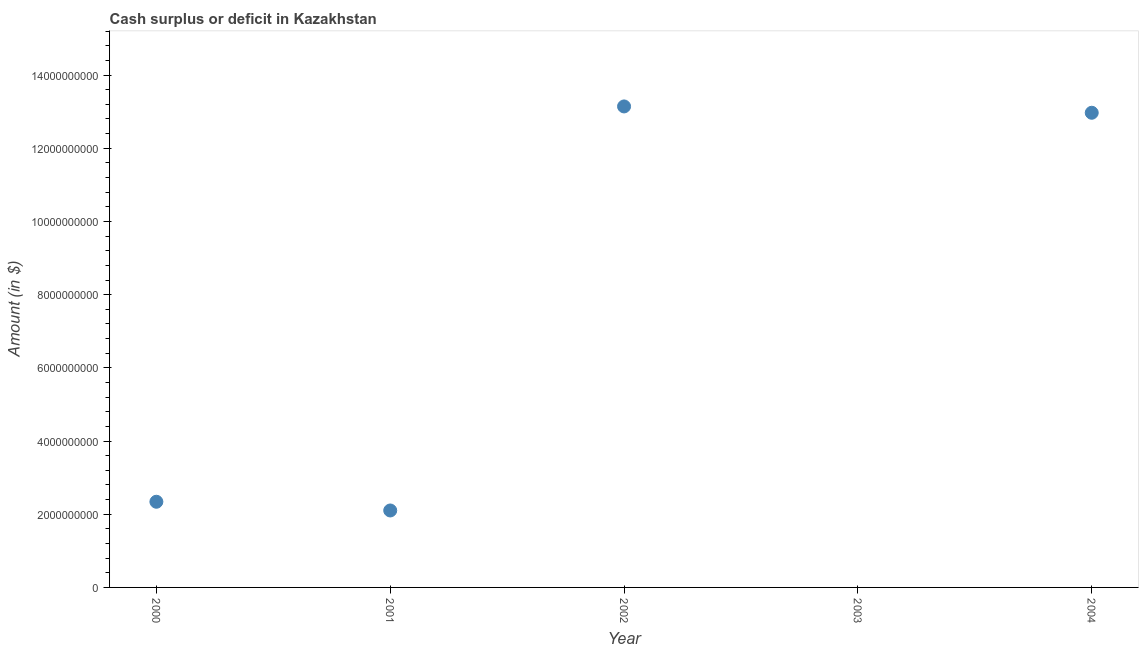What is the cash surplus or deficit in 2002?
Your response must be concise. 1.31e+1. Across all years, what is the maximum cash surplus or deficit?
Offer a very short reply. 1.31e+1. In which year was the cash surplus or deficit maximum?
Your answer should be compact. 2002. What is the sum of the cash surplus or deficit?
Offer a terse response. 3.06e+1. What is the difference between the cash surplus or deficit in 2000 and 2002?
Ensure brevity in your answer.  -1.08e+1. What is the average cash surplus or deficit per year?
Your answer should be very brief. 6.11e+09. What is the median cash surplus or deficit?
Offer a very short reply. 2.34e+09. In how many years, is the cash surplus or deficit greater than 3200000000 $?
Give a very brief answer. 2. What is the ratio of the cash surplus or deficit in 2002 to that in 2004?
Offer a very short reply. 1.01. What is the difference between the highest and the second highest cash surplus or deficit?
Make the answer very short. 1.73e+08. What is the difference between the highest and the lowest cash surplus or deficit?
Offer a terse response. 1.31e+1. In how many years, is the cash surplus or deficit greater than the average cash surplus or deficit taken over all years?
Make the answer very short. 2. What is the difference between two consecutive major ticks on the Y-axis?
Provide a short and direct response. 2.00e+09. Are the values on the major ticks of Y-axis written in scientific E-notation?
Provide a short and direct response. No. Does the graph contain any zero values?
Make the answer very short. Yes. What is the title of the graph?
Make the answer very short. Cash surplus or deficit in Kazakhstan. What is the label or title of the X-axis?
Your answer should be very brief. Year. What is the label or title of the Y-axis?
Keep it short and to the point. Amount (in $). What is the Amount (in $) in 2000?
Offer a terse response. 2.34e+09. What is the Amount (in $) in 2001?
Offer a terse response. 2.10e+09. What is the Amount (in $) in 2002?
Keep it short and to the point. 1.31e+1. What is the Amount (in $) in 2004?
Your answer should be compact. 1.30e+1. What is the difference between the Amount (in $) in 2000 and 2001?
Your response must be concise. 2.38e+08. What is the difference between the Amount (in $) in 2000 and 2002?
Ensure brevity in your answer.  -1.08e+1. What is the difference between the Amount (in $) in 2000 and 2004?
Give a very brief answer. -1.06e+1. What is the difference between the Amount (in $) in 2001 and 2002?
Your response must be concise. -1.10e+1. What is the difference between the Amount (in $) in 2001 and 2004?
Provide a succinct answer. -1.09e+1. What is the difference between the Amount (in $) in 2002 and 2004?
Offer a very short reply. 1.73e+08. What is the ratio of the Amount (in $) in 2000 to that in 2001?
Provide a short and direct response. 1.11. What is the ratio of the Amount (in $) in 2000 to that in 2002?
Your answer should be compact. 0.18. What is the ratio of the Amount (in $) in 2000 to that in 2004?
Keep it short and to the point. 0.18. What is the ratio of the Amount (in $) in 2001 to that in 2002?
Give a very brief answer. 0.16. What is the ratio of the Amount (in $) in 2001 to that in 2004?
Give a very brief answer. 0.16. 